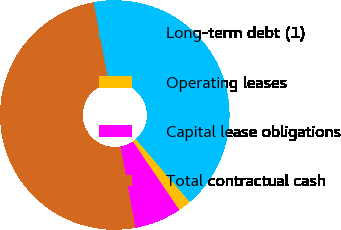<chart> <loc_0><loc_0><loc_500><loc_500><pie_chart><fcel>Long-term debt (1)<fcel>Operating leases<fcel>Capital lease obligations<fcel>Total contractual cash<nl><fcel>41.66%<fcel>1.82%<fcel>6.62%<fcel>49.9%<nl></chart> 